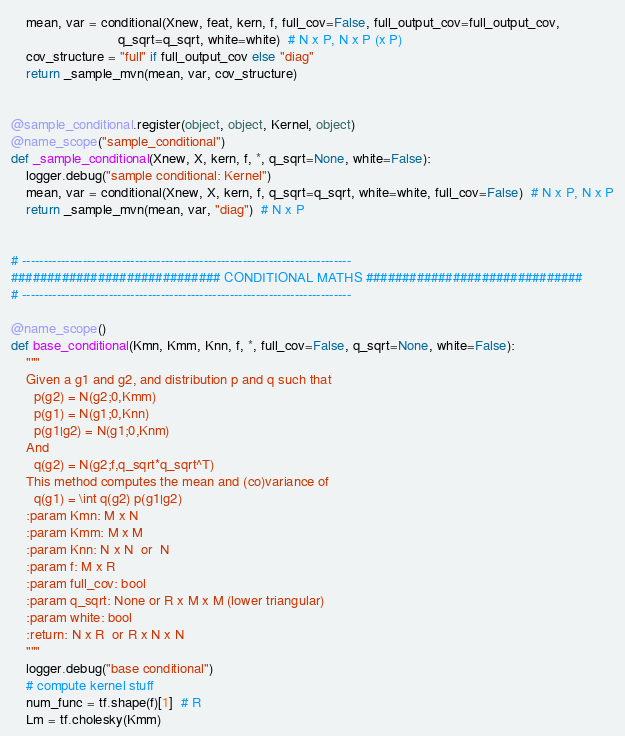<code> <loc_0><loc_0><loc_500><loc_500><_Python_>    mean, var = conditional(Xnew, feat, kern, f, full_cov=False, full_output_cov=full_output_cov,
                            q_sqrt=q_sqrt, white=white)  # N x P, N x P (x P)
    cov_structure = "full" if full_output_cov else "diag"
    return _sample_mvn(mean, var, cov_structure)


@sample_conditional.register(object, object, Kernel, object)
@name_scope("sample_conditional")
def _sample_conditional(Xnew, X, kern, f, *, q_sqrt=None, white=False):
    logger.debug("sample conditional: Kernel")
    mean, var = conditional(Xnew, X, kern, f, q_sqrt=q_sqrt, white=white, full_cov=False)  # N x P, N x P
    return _sample_mvn(mean, var, "diag")  # N x P


# ----------------------------------------------------------------------------
############################# CONDITIONAL MATHS ##############################
# ----------------------------------------------------------------------------

@name_scope()
def base_conditional(Kmn, Kmm, Knn, f, *, full_cov=False, q_sqrt=None, white=False):
    """
    Given a g1 and g2, and distribution p and q such that
      p(g2) = N(g2;0,Kmm)
      p(g1) = N(g1;0,Knn)
      p(g1|g2) = N(g1;0,Knm)
    And
      q(g2) = N(g2;f,q_sqrt*q_sqrt^T)
    This method computes the mean and (co)variance of
      q(g1) = \int q(g2) p(g1|g2)
    :param Kmn: M x N
    :param Kmm: M x M
    :param Knn: N x N  or  N
    :param f: M x R
    :param full_cov: bool
    :param q_sqrt: None or R x M x M (lower triangular)
    :param white: bool
    :return: N x R  or R x N x N
    """
    logger.debug("base conditional")
    # compute kernel stuff
    num_func = tf.shape(f)[1]  # R
    Lm = tf.cholesky(Kmm)
</code> 